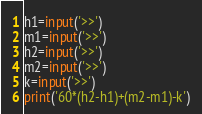Convert code to text. <code><loc_0><loc_0><loc_500><loc_500><_Python_>h1=input('>>')
m1=input('>>')
h2=input('>>')
m2=input('>>')
k=input('>>')
print('60*(h2-h1)+(m2-m1)-k')







</code> 